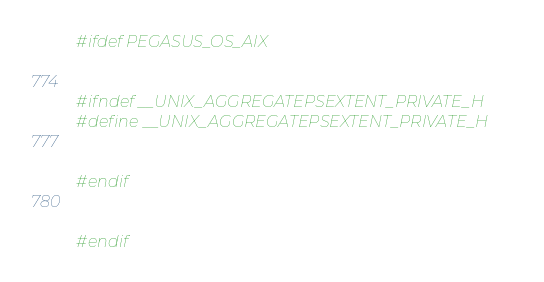Convert code to text. <code><loc_0><loc_0><loc_500><loc_500><_C++_>#ifdef PEGASUS_OS_AIX


#ifndef __UNIX_AGGREGATEPSEXTENT_PRIVATE_H
#define __UNIX_AGGREGATEPSEXTENT_PRIVATE_H


#endif


#endif
</code> 